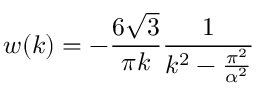<formula> <loc_0><loc_0><loc_500><loc_500>w ( k ) = - \frac { 6 \sqrt { 3 } } { \pi k } \frac { 1 } { k ^ { 2 } - \frac { \pi ^ { 2 } } { \alpha ^ { 2 } } }</formula> 